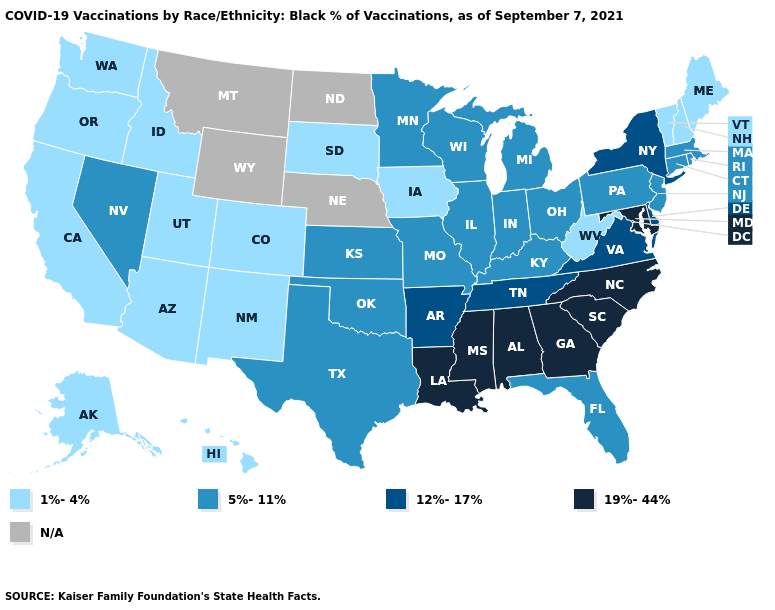What is the value of Washington?
Answer briefly. 1%-4%. What is the value of Colorado?
Short answer required. 1%-4%. Among the states that border Iowa , does Wisconsin have the lowest value?
Keep it brief. No. What is the value of Idaho?
Keep it brief. 1%-4%. Among the states that border Arkansas , does Missouri have the lowest value?
Quick response, please. Yes. What is the lowest value in the Northeast?
Give a very brief answer. 1%-4%. Which states have the lowest value in the USA?
Be succinct. Alaska, Arizona, California, Colorado, Hawaii, Idaho, Iowa, Maine, New Hampshire, New Mexico, Oregon, South Dakota, Utah, Vermont, Washington, West Virginia. Name the states that have a value in the range 1%-4%?
Give a very brief answer. Alaska, Arizona, California, Colorado, Hawaii, Idaho, Iowa, Maine, New Hampshire, New Mexico, Oregon, South Dakota, Utah, Vermont, Washington, West Virginia. What is the value of Wisconsin?
Give a very brief answer. 5%-11%. What is the value of Virginia?
Answer briefly. 12%-17%. Which states have the lowest value in the USA?
Answer briefly. Alaska, Arizona, California, Colorado, Hawaii, Idaho, Iowa, Maine, New Hampshire, New Mexico, Oregon, South Dakota, Utah, Vermont, Washington, West Virginia. Name the states that have a value in the range 1%-4%?
Concise answer only. Alaska, Arizona, California, Colorado, Hawaii, Idaho, Iowa, Maine, New Hampshire, New Mexico, Oregon, South Dakota, Utah, Vermont, Washington, West Virginia. Name the states that have a value in the range 12%-17%?
Be succinct. Arkansas, Delaware, New York, Tennessee, Virginia. What is the lowest value in the USA?
Be succinct. 1%-4%. 